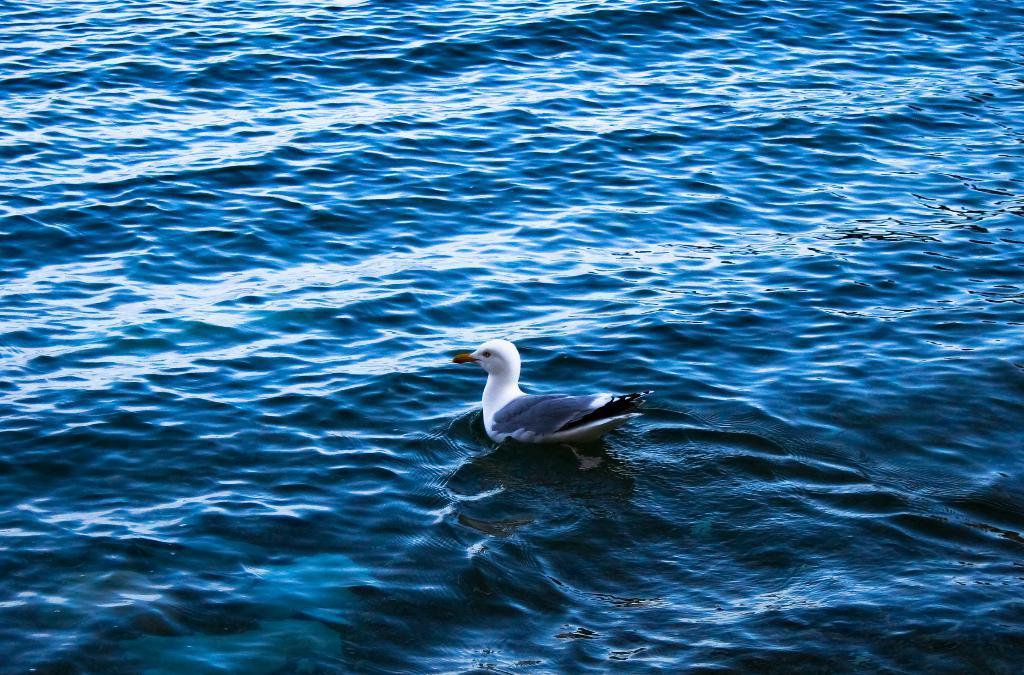In one or two sentences, can you explain what this image depicts? In this image, this looks like a sea bird named as albatross, which is in the water. 